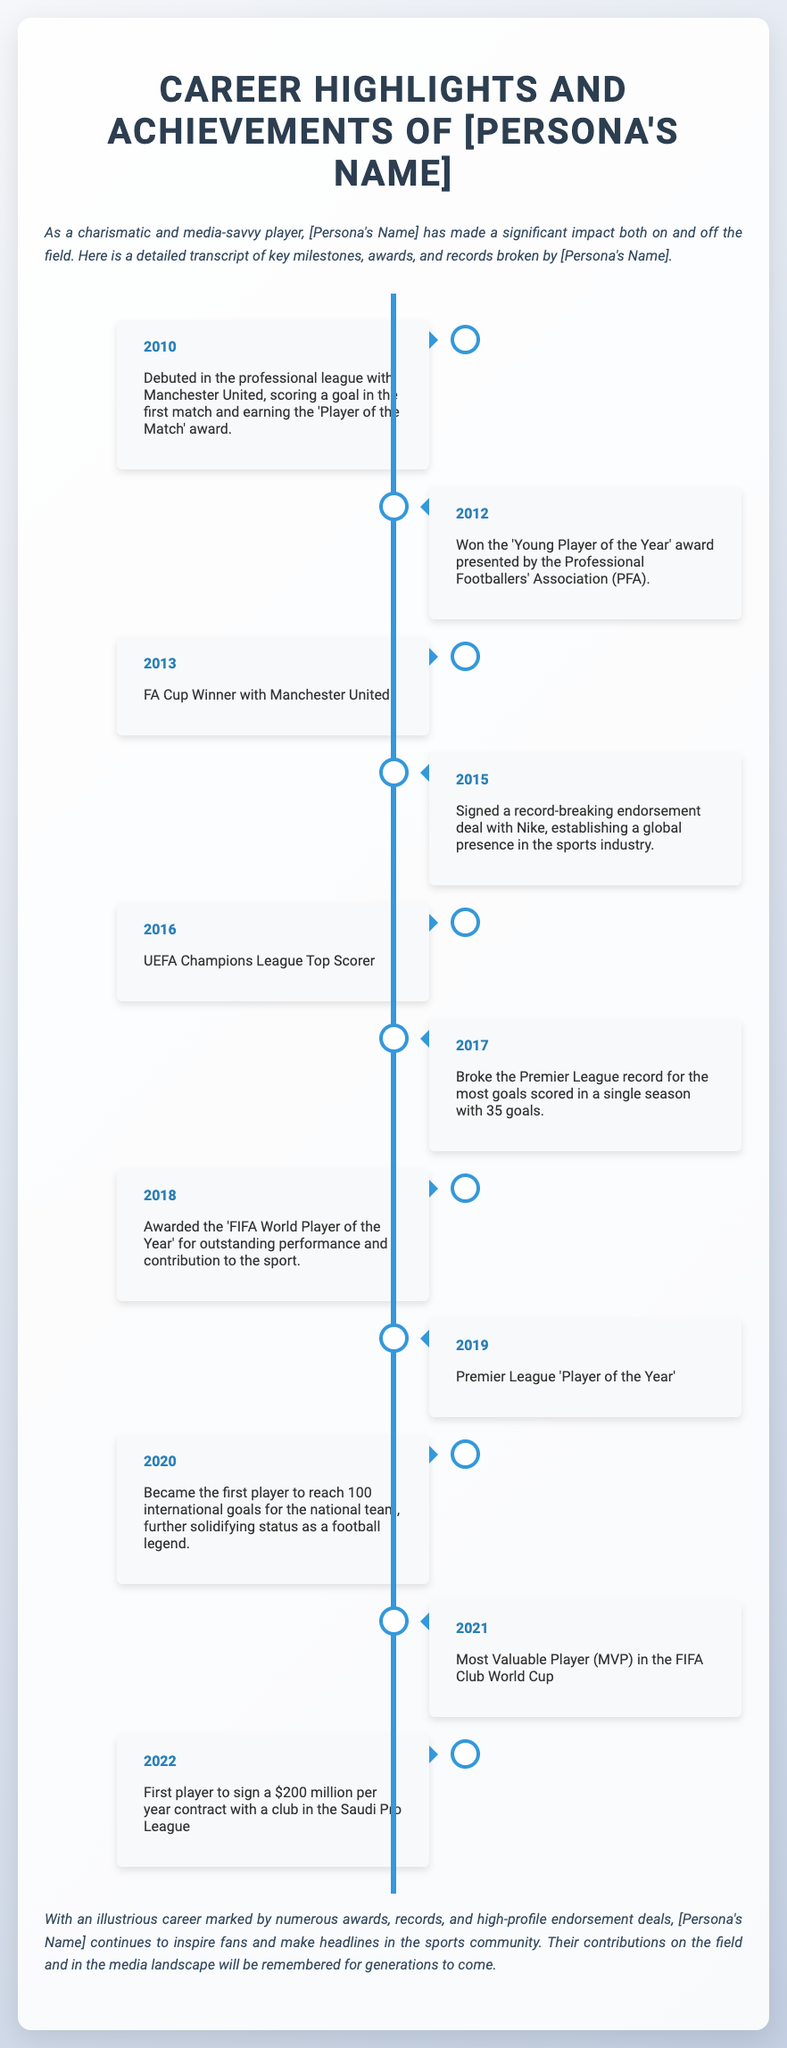What year did [Persona's Name] debut in the professional league? The document states that [Persona's Name] debuted in the professional league in 2010.
Answer: 2010 Which award did [Persona's Name] win in 2012? The document mentions that [Persona's Name] won the 'Young Player of the Year' award in 2012.
Answer: Young Player of the Year How many goals did [Persona's Name] score to break the Premier League record in 2017? According to the document, [Persona's Name] broke the Premier League record by scoring 35 goals in 2017.
Answer: 35 What significant milestone did [Persona's Name] achieve in 2020? The document highlights that [Persona's Name] became the first player to reach 100 international goals for the national team in 2020.
Answer: 100 international goals What is the value of the contract [Persona's Name] signed in 2022? The document states that [Persona's Name] signed a $200 million per year contract in 2022.
Answer: $200 million Which team did [Persona's Name] debut with? The document indicates that [Persona's Name] debuted with Manchester United.
Answer: Manchester United What award was [Persona's Name] recognized with in 2018? The document reveals that [Persona's Name] was awarded the 'FIFA World Player of the Year' in 2018.
Answer: FIFA World Player of the Year What year did [Persona's Name] become UEFA Champions League Top Scorer? The document states that [Persona's Name] was the UEFA Champions League Top Scorer in 2016.
Answer: 2016 